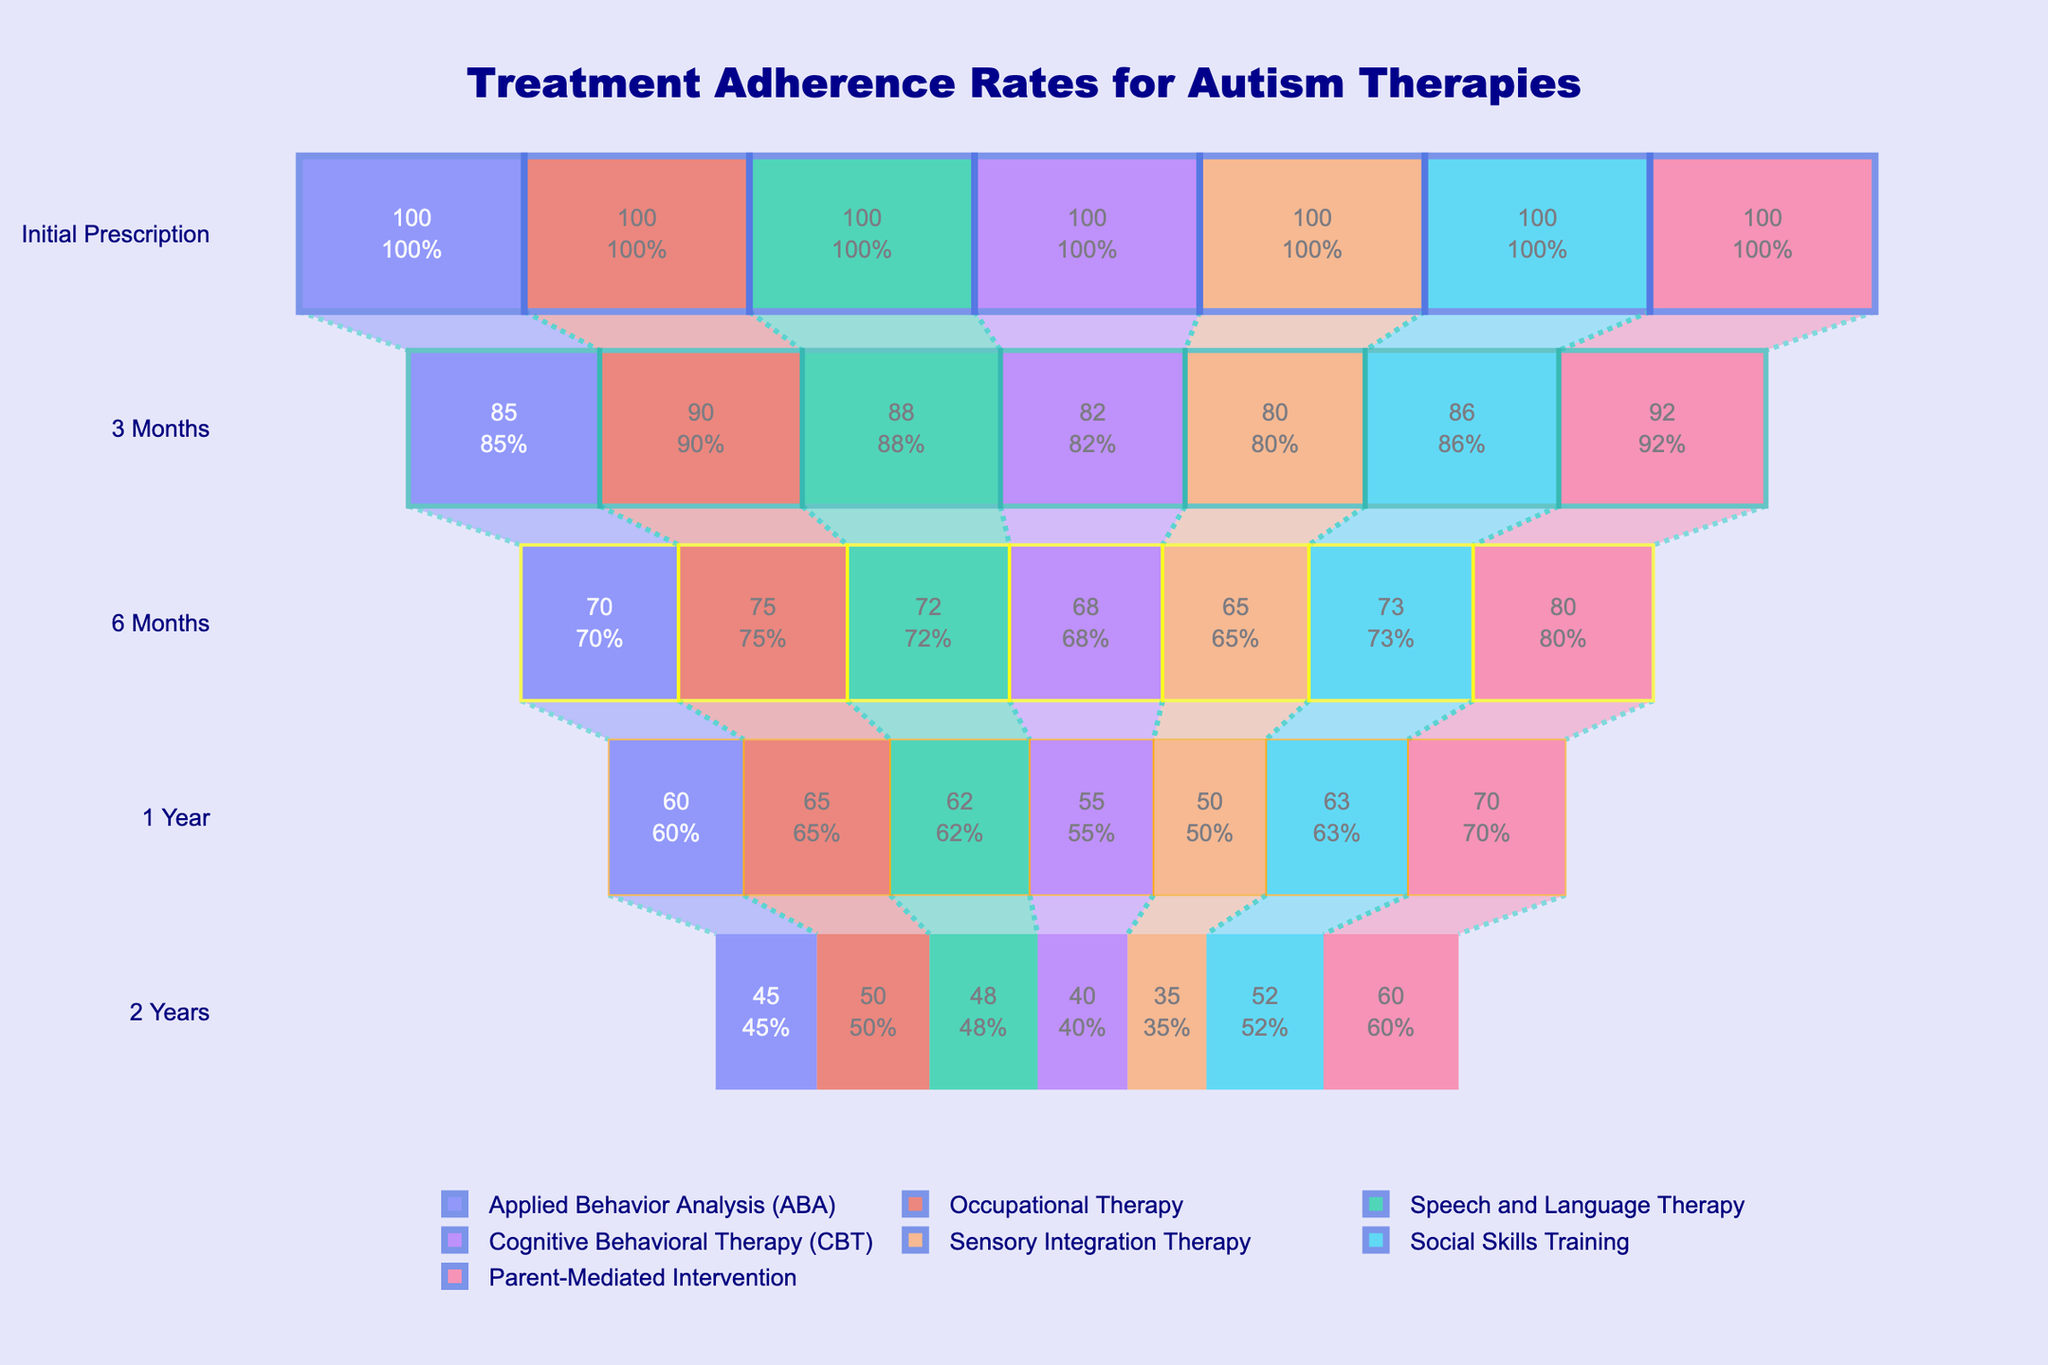What is the title of the figure? The title is provided in the layout of the figure, typically at the top in larger and bolder font.
Answer: Treatment Adherence Rates for Autism Therapies How many therapy types are represented in the figure? By observing the legend or the number of funnel traces, we can count the number of different therapy names.
Answer: 7 Which therapy has the highest percentage adherence at 2 years? Look for the highest value in the column labeled "2 Years" for each of the therapy traces.
Answer: Parent-Mediated Intervention What is the drop in adherence for Cognitive Behavioral Therapy (CBT) from 6 months to 2 years? Find the difference between the values given for "6 Months" and "2 Years" for CBT.
Answer: 28 (68 - 40) Which two therapies maintain at least 50% adherence at 2 years? Identify the therapies with values of 50% or higher in the "2 Years" column.
Answer: Occupational Therapy, Social Skills Training, Parent-Mediated Intervention Compare the adherence rate at 1 year between Applied Behavior Analysis (ABA) and Sensory Integration Therapy. Which is higher? Look at the values for both therapies in the "1 Year" column and compare them.
Answer: Applied Behavior Analysis (ABA) Calculate the average adherence rate at 3 months across all therapies. Sum the values given for "3 Months" for each therapy and divide by the number of therapies.
Answer: 86 (602/7) Which therapy shows the steepest decline in adherence from initial prescription to 2 years? Calculate the difference for each therapy from "Initial Prescription" to "2 Years" and find the largest decrease.
Answer: Sensory Integration Therapy At the 6-month point, what is the difference in adherence rates between Occupational Therapy and Speech and Language Therapy? Subtract Speech and Language Therapy's value in "6 Months" column from Occupational Therapy's value in the same column.
Answer: 3 (75 - 72) How does the adherence rate for Parent-Mediated Intervention change from 1 year to 2 years? Find the values for Parent-Mediated Intervention at "1 Year" and "2 Years" and calculate the difference.
Answer: -10 (70 - 60) 